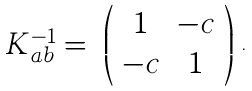Convert formula to latex. <formula><loc_0><loc_0><loc_500><loc_500>\begin{array} { c c } K _ { a b } ^ { - 1 } = & \left ( \begin{array} { c c } 1 & - c \\ - c & 1 \end{array} \right ) \end{array} .</formula> 